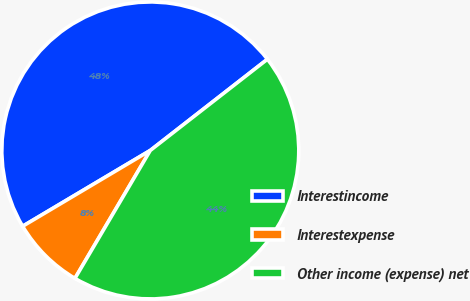<chart> <loc_0><loc_0><loc_500><loc_500><pie_chart><fcel>Interestincome<fcel>Interestexpense<fcel>Other income (expense) net<nl><fcel>48.0%<fcel>8.0%<fcel>44.0%<nl></chart> 